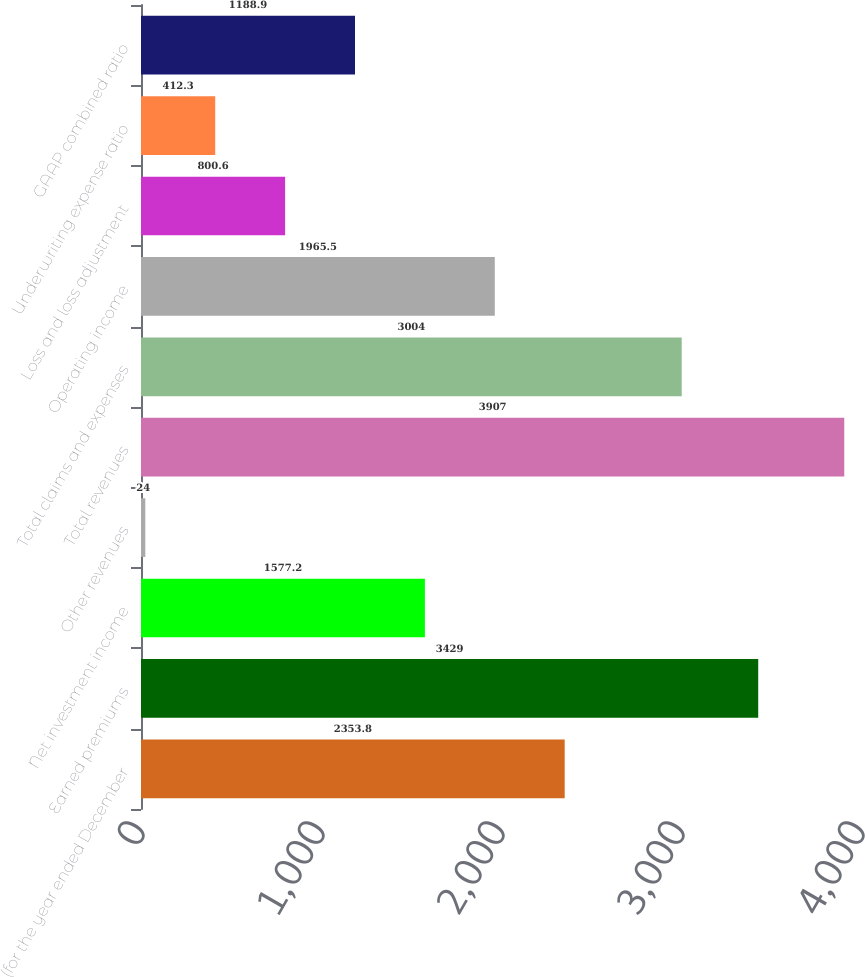Convert chart. <chart><loc_0><loc_0><loc_500><loc_500><bar_chart><fcel>(for the year ended December<fcel>Earned premiums<fcel>Net investment income<fcel>Other revenues<fcel>Total revenues<fcel>Total claims and expenses<fcel>Operating income<fcel>Loss and loss adjustment<fcel>Underwriting expense ratio<fcel>GAAP combined ratio<nl><fcel>2353.8<fcel>3429<fcel>1577.2<fcel>24<fcel>3907<fcel>3004<fcel>1965.5<fcel>800.6<fcel>412.3<fcel>1188.9<nl></chart> 